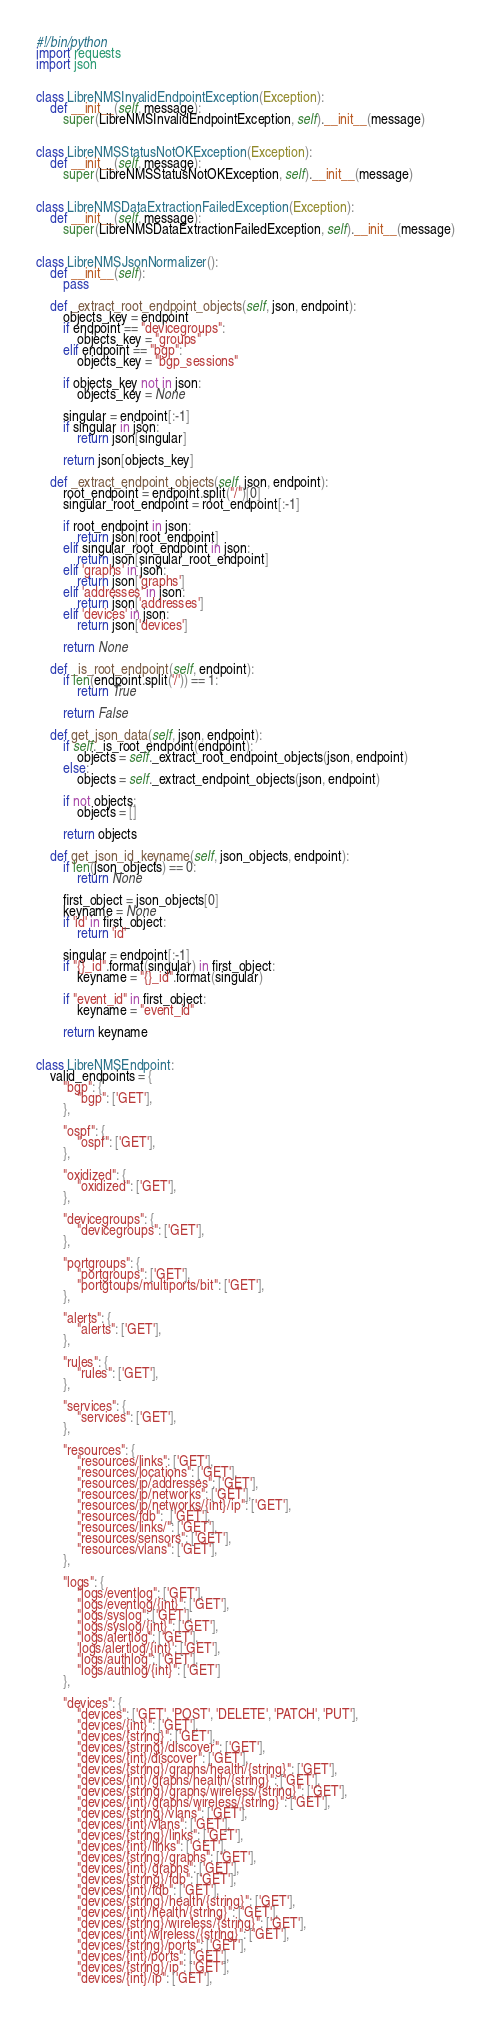Convert code to text. <code><loc_0><loc_0><loc_500><loc_500><_Python_>#!/bin/python
import requests
import json


class LibreNMSInvalidEndpointException(Exception):
    def __init__(self, message):
        super(LibreNMSInvalidEndpointException, self).__init__(message)


class LibreNMSStatusNotOKException(Exception):
    def __init__(self, message):
        super(LibreNMSStatusNotOKException, self).__init__(message)


class LibreNMSDataExtractionFailedException(Exception):
    def __init__(self, message):
        super(LibreNMSDataExtractionFailedException, self).__init__(message)


class LibreNMSJsonNormalizer():
    def __init__(self):
        pass

    def _extract_root_endpoint_objects(self, json, endpoint):
        objects_key = endpoint
        if endpoint == "devicegroups":
            objects_key = "groups"
        elif endpoint == "bgp":
            objects_key = "bgp_sessions"

        if objects_key not in json:
            objects_key = None

        singular = endpoint[:-1]
        if singular in json:
            return json[singular]

        return json[objects_key]

    def _extract_endpoint_objects(self, json, endpoint):
        root_endpoint = endpoint.split("/")[0]
        singular_root_endpoint = root_endpoint[:-1]

        if root_endpoint in json:
            return json[root_endpoint]
        elif singular_root_endpoint in json:
            return json[singular_root_endpoint]
        elif 'graphs' in json:
            return json['graphs']
        elif 'addresses' in json:
            return json['addresses']
        elif 'devices' in json:
            return json['devices']

        return None

    def _is_root_endpoint(self, endpoint):
        if len(endpoint.split('/')) == 1:
            return True

        return False

    def get_json_data(self, json, endpoint):
        if self._is_root_endpoint(endpoint):
            objects = self._extract_root_endpoint_objects(json, endpoint)
        else:
            objects = self._extract_endpoint_objects(json, endpoint)

        if not objects:
            objects = []

        return objects

    def get_json_id_keyname(self, json_objects, endpoint):
        if len(json_objects) == 0:
            return None

        first_object = json_objects[0]
        keyname = None
        if 'id' in first_object:
            return 'id'

        singular = endpoint[:-1]
        if "{}_id".format(singular) in first_object:
            keyname = "{}_id".format(singular)

        if "event_id" in first_object:
            keyname = "event_id"

        return keyname


class LibreNMSEndpoint:
    valid_endpoints = {
        "bgp": {
            "bgp": ['GET'],
        },

        "ospf": {
            "ospf": ['GET'],
        },

        "oxidized": {
            "oxidized": ['GET'],
        },

        "devicegroups": {
            "devicegroups": ['GET'],
        },

        "portgroups": {
            "portgroups": ['GET'],
            "portgtoups/multiports/bit": ['GET'],
        },

        "alerts": {
            "alerts": ['GET'],
        },

        "rules": {
            "rules": ['GET'],
        },

        "services": {
            "services": ['GET'],
        },

        "resources": {
            "resources/links": ['GET'],
            "resources/locations": ['GET'],
            "resources/ip/addresses": ['GET'],
            "resources/ip/networks": ['GET'],
            "resources/ip/networks/{int}/ip": ['GET'],
            "resources/fdb":  ['GET'],
            "resources/links/": ['GET'],
            "resources/sensors": ['GET'],
            "resources/vlans": ['GET'],
        },

        "logs": {
            "logs/eventlog": ['GET'],
            "logs/eventlog/{int}": ['GET'],
            "logs/syslog": ['GET'],
            "logs/syslog/{int}": ['GET'],
            "logs/alertlog": ['GET'],
            'logs/alertlog/{int}': ['GET'],
            "logs/authlog": ['GET'],
            "logs/authlog/{int}": ['GET']
        },

        "devices": {
            "devices": ['GET', 'POST', 'DELETE', 'PATCH', 'PUT'],
            "devices/{int}": ['GET'],
            "devices/{string}": ['GET'],
            "devices/{string}/discover": ['GET'],
            "devices/{int}/discover": ['GET'],
            "devices/{string}/graphs/health/{string}": ['GET'],
            "devices/{int}/graphs/health/{string}": ['GET'],
            "devices/{string}/graphs/wireless/{string}": ['GET'],
            "devices/{int}/graphs/wireless/{string}": ['GET'],
            "devices/{string}/vlans": ['GET'],
            "devices/{int}/vlans": ['GET'],
            "devices/{string}/links": ['GET'],
            "devices/{int}/links": ['GET'],
            "devices/{string}/graphs": ['GET'],
            "devices/{int}/graphs": ['GET'],
            "devices/{string}/fdb": ['GET'],
            "devices/{int}/fdb": ['GET'],
            "devices/{string}/health/{string}": ['GET'],
            "devices/{int}/health/{string}": ['GET'],
            "devices/{string}/wireless/{string}": ['GET'],
            "devices/{int}/wireless/{string}": ['GET'],
            "devices/{string}/ports": ['GET'],
            "devices/{int}/ports": ['GET'],
            "devices/{string}/ip": ['GET'],
            "devices/{int}/ip": ['GET'],</code> 